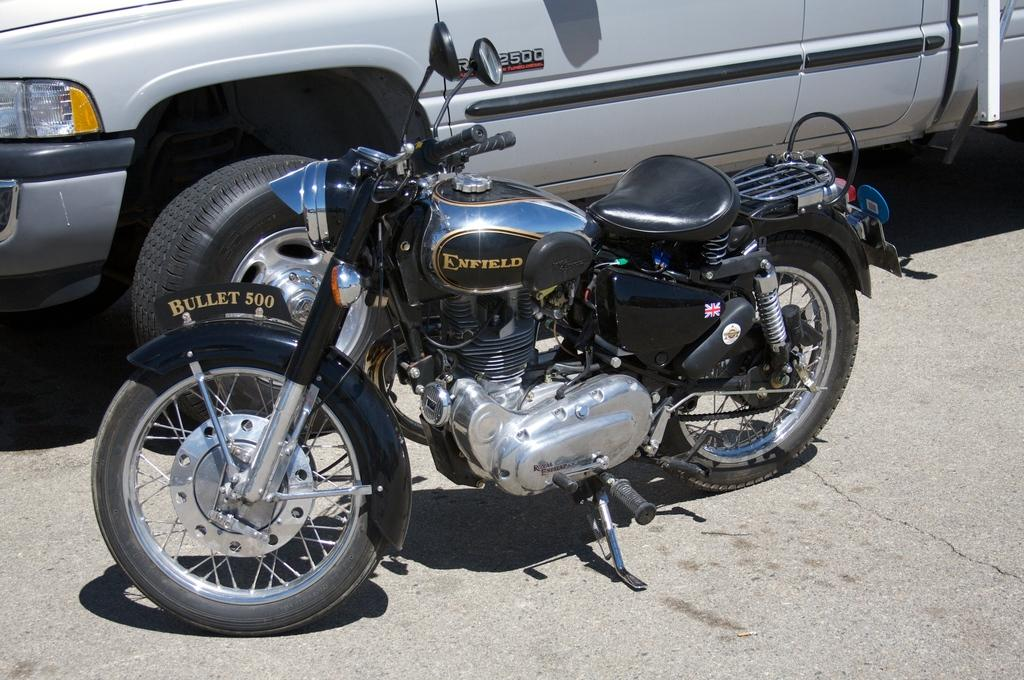What type of vehicle is in the image? There is an enfield bike in the image. What colors can be seen on the bike? The bike has a silver and black color. Where is the bike located in the image? The bike is parked on the road. What else can be seen in the background of the image? There is a silver car in the background of the image. How does the bike jump over the bridge in the image? The bike does not jump over a bridge in the image; it is parked on the road. What type of breath can be seen coming from the bike's exhaust in the image? There is no breath coming from the bike's exhaust in the image, as it is parked and not running. 